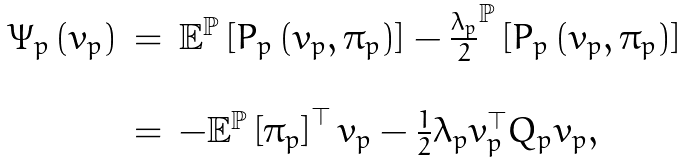<formula> <loc_0><loc_0><loc_500><loc_500>\begin{array} { r c l } \Psi _ { p } \left ( v _ { p } \right ) & = & \mathbb { E } ^ { \mathbb { P } } \left [ P _ { p } \left ( v _ { p } , \pi _ { p } \right ) \right ] - \frac { \lambda _ { p } } { 2 } ^ { \mathbb { P } } \left [ P _ { p } \left ( v _ { p } , \pi _ { p } \right ) \right ] \\ \\ & = & - \mathbb { E } ^ { \mathbb { P } } \left [ \pi _ { p } \right ] ^ { \top } v _ { p } - \frac { 1 } { 2 } \lambda _ { p } v _ { p } ^ { \top } Q _ { p } v _ { p } , \end{array}</formula> 